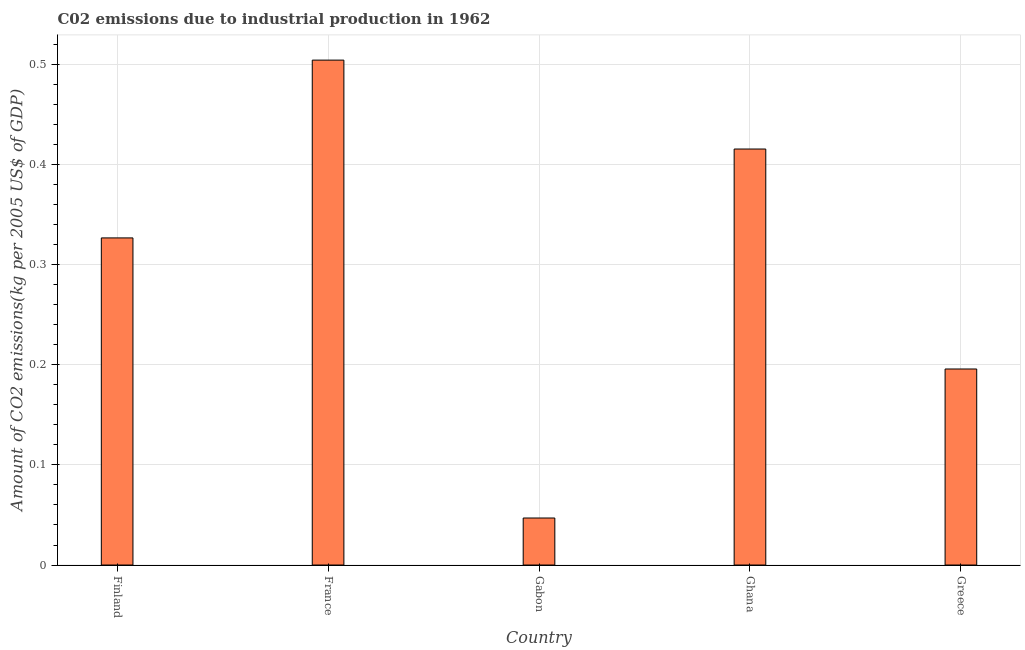What is the title of the graph?
Your response must be concise. C02 emissions due to industrial production in 1962. What is the label or title of the Y-axis?
Your answer should be very brief. Amount of CO2 emissions(kg per 2005 US$ of GDP). What is the amount of co2 emissions in Gabon?
Provide a short and direct response. 0.05. Across all countries, what is the maximum amount of co2 emissions?
Offer a terse response. 0.5. Across all countries, what is the minimum amount of co2 emissions?
Offer a terse response. 0.05. In which country was the amount of co2 emissions maximum?
Give a very brief answer. France. In which country was the amount of co2 emissions minimum?
Offer a very short reply. Gabon. What is the sum of the amount of co2 emissions?
Keep it short and to the point. 1.49. What is the difference between the amount of co2 emissions in France and Ghana?
Provide a short and direct response. 0.09. What is the average amount of co2 emissions per country?
Offer a very short reply. 0.3. What is the median amount of co2 emissions?
Provide a succinct answer. 0.33. What is the ratio of the amount of co2 emissions in Gabon to that in Greece?
Keep it short and to the point. 0.24. Is the amount of co2 emissions in France less than that in Greece?
Offer a very short reply. No. Is the difference between the amount of co2 emissions in Ghana and Greece greater than the difference between any two countries?
Keep it short and to the point. No. What is the difference between the highest and the second highest amount of co2 emissions?
Offer a terse response. 0.09. What is the difference between the highest and the lowest amount of co2 emissions?
Provide a succinct answer. 0.46. In how many countries, is the amount of co2 emissions greater than the average amount of co2 emissions taken over all countries?
Your response must be concise. 3. Are all the bars in the graph horizontal?
Offer a terse response. No. How many countries are there in the graph?
Ensure brevity in your answer.  5. What is the Amount of CO2 emissions(kg per 2005 US$ of GDP) of Finland?
Give a very brief answer. 0.33. What is the Amount of CO2 emissions(kg per 2005 US$ of GDP) in France?
Your answer should be very brief. 0.5. What is the Amount of CO2 emissions(kg per 2005 US$ of GDP) in Gabon?
Ensure brevity in your answer.  0.05. What is the Amount of CO2 emissions(kg per 2005 US$ of GDP) in Ghana?
Provide a succinct answer. 0.42. What is the Amount of CO2 emissions(kg per 2005 US$ of GDP) of Greece?
Give a very brief answer. 0.2. What is the difference between the Amount of CO2 emissions(kg per 2005 US$ of GDP) in Finland and France?
Provide a short and direct response. -0.18. What is the difference between the Amount of CO2 emissions(kg per 2005 US$ of GDP) in Finland and Gabon?
Keep it short and to the point. 0.28. What is the difference between the Amount of CO2 emissions(kg per 2005 US$ of GDP) in Finland and Ghana?
Your response must be concise. -0.09. What is the difference between the Amount of CO2 emissions(kg per 2005 US$ of GDP) in Finland and Greece?
Offer a terse response. 0.13. What is the difference between the Amount of CO2 emissions(kg per 2005 US$ of GDP) in France and Gabon?
Provide a short and direct response. 0.46. What is the difference between the Amount of CO2 emissions(kg per 2005 US$ of GDP) in France and Ghana?
Offer a terse response. 0.09. What is the difference between the Amount of CO2 emissions(kg per 2005 US$ of GDP) in France and Greece?
Offer a very short reply. 0.31. What is the difference between the Amount of CO2 emissions(kg per 2005 US$ of GDP) in Gabon and Ghana?
Give a very brief answer. -0.37. What is the difference between the Amount of CO2 emissions(kg per 2005 US$ of GDP) in Gabon and Greece?
Your answer should be compact. -0.15. What is the difference between the Amount of CO2 emissions(kg per 2005 US$ of GDP) in Ghana and Greece?
Give a very brief answer. 0.22. What is the ratio of the Amount of CO2 emissions(kg per 2005 US$ of GDP) in Finland to that in France?
Offer a very short reply. 0.65. What is the ratio of the Amount of CO2 emissions(kg per 2005 US$ of GDP) in Finland to that in Gabon?
Provide a short and direct response. 6.96. What is the ratio of the Amount of CO2 emissions(kg per 2005 US$ of GDP) in Finland to that in Ghana?
Provide a short and direct response. 0.79. What is the ratio of the Amount of CO2 emissions(kg per 2005 US$ of GDP) in Finland to that in Greece?
Offer a terse response. 1.67. What is the ratio of the Amount of CO2 emissions(kg per 2005 US$ of GDP) in France to that in Gabon?
Make the answer very short. 10.74. What is the ratio of the Amount of CO2 emissions(kg per 2005 US$ of GDP) in France to that in Ghana?
Your answer should be very brief. 1.21. What is the ratio of the Amount of CO2 emissions(kg per 2005 US$ of GDP) in France to that in Greece?
Offer a very short reply. 2.58. What is the ratio of the Amount of CO2 emissions(kg per 2005 US$ of GDP) in Gabon to that in Ghana?
Your answer should be compact. 0.11. What is the ratio of the Amount of CO2 emissions(kg per 2005 US$ of GDP) in Gabon to that in Greece?
Your answer should be very brief. 0.24. What is the ratio of the Amount of CO2 emissions(kg per 2005 US$ of GDP) in Ghana to that in Greece?
Give a very brief answer. 2.12. 